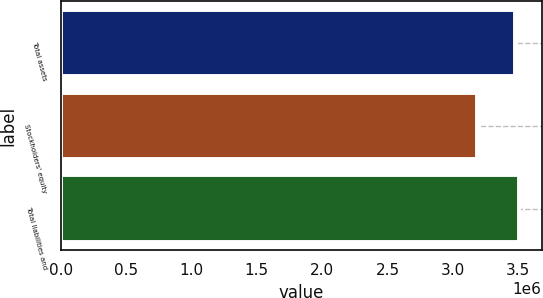Convert chart. <chart><loc_0><loc_0><loc_500><loc_500><bar_chart><fcel>Total assets<fcel>Stockholders' equity<fcel>Total liabilities and<nl><fcel>3.4738e+06<fcel>3.18277e+06<fcel>3.5029e+06<nl></chart> 